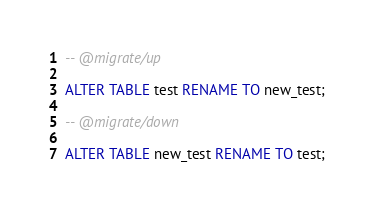Convert code to text. <code><loc_0><loc_0><loc_500><loc_500><_SQL_>-- @migrate/up

ALTER TABLE test RENAME TO new_test;

-- @migrate/down

ALTER TABLE new_test RENAME TO test;
</code> 